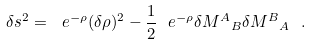Convert formula to latex. <formula><loc_0><loc_0><loc_500><loc_500>\delta s ^ { 2 } = \ e ^ { - \rho } ( \delta \rho ) ^ { 2 } - \frac { 1 } { 2 } \ e ^ { - \rho } \delta { M ^ { A } } _ { B } \delta { M ^ { B } } _ { A } \ .</formula> 